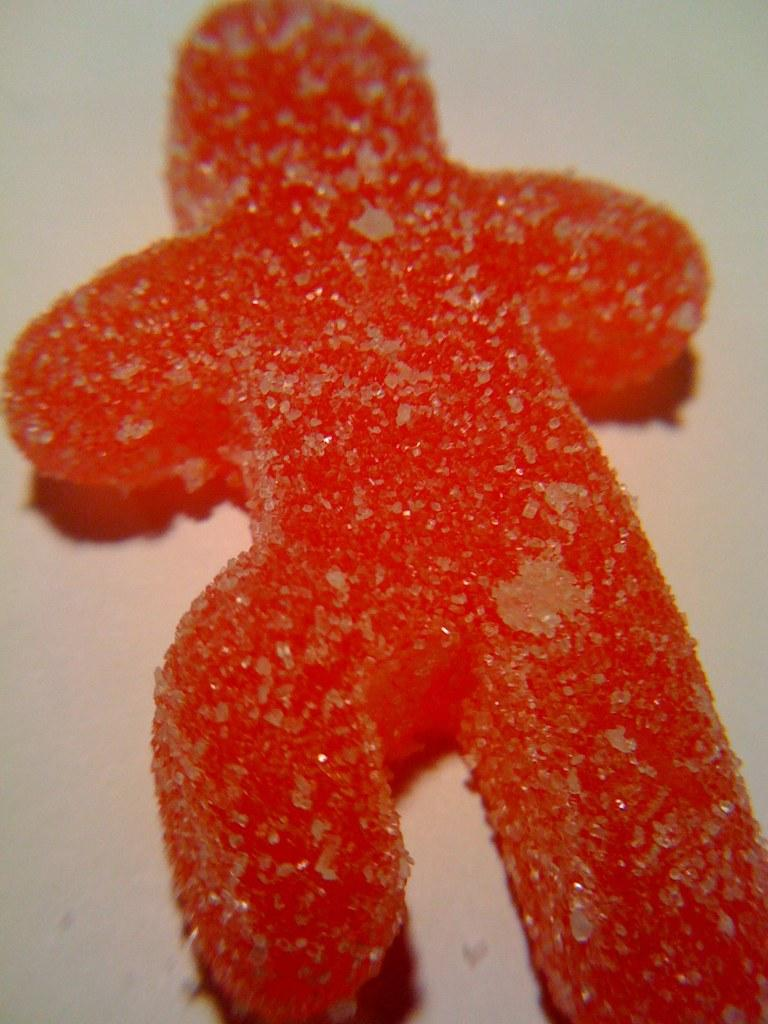What type of food is present in the image? There is a candy in the image. How is the candy coated? The candy is coated with sugar. Is there a visitor involved in an argument with the candy in the image? No, there is no visitor or argument present in the image; it only features a candy coated with sugar. 